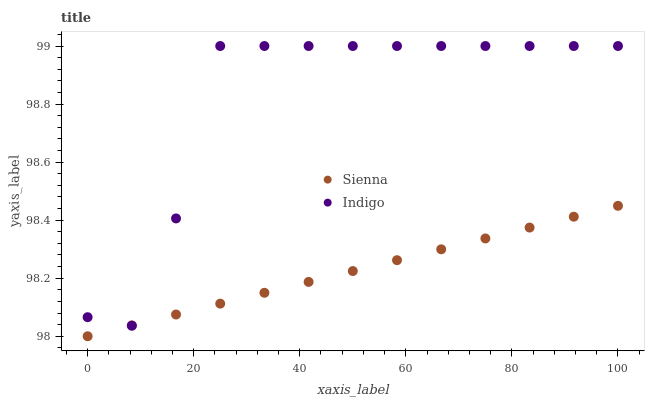Does Sienna have the minimum area under the curve?
Answer yes or no. Yes. Does Indigo have the maximum area under the curve?
Answer yes or no. Yes. Does Indigo have the minimum area under the curve?
Answer yes or no. No. Is Sienna the smoothest?
Answer yes or no. Yes. Is Indigo the roughest?
Answer yes or no. Yes. Is Indigo the smoothest?
Answer yes or no. No. Does Sienna have the lowest value?
Answer yes or no. Yes. Does Indigo have the lowest value?
Answer yes or no. No. Does Indigo have the highest value?
Answer yes or no. Yes. Does Sienna intersect Indigo?
Answer yes or no. Yes. Is Sienna less than Indigo?
Answer yes or no. No. Is Sienna greater than Indigo?
Answer yes or no. No. 